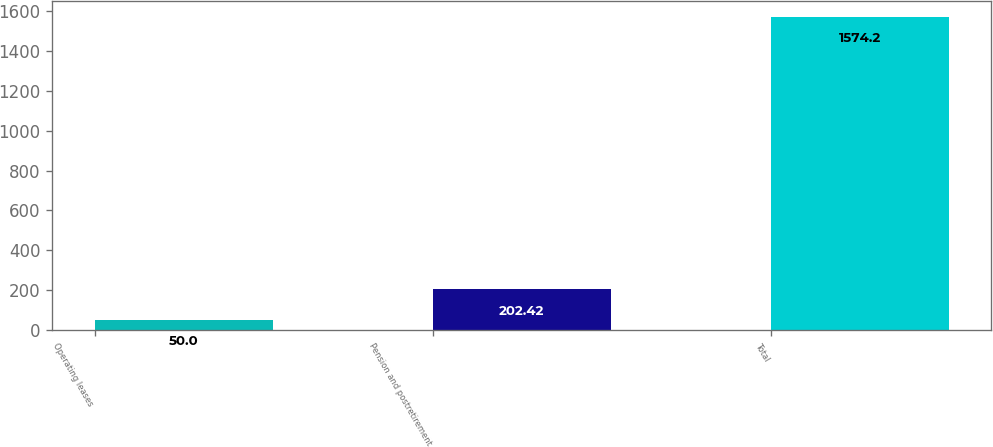<chart> <loc_0><loc_0><loc_500><loc_500><bar_chart><fcel>Operating leases<fcel>Pension and postretirement<fcel>Total<nl><fcel>50<fcel>202.42<fcel>1574.2<nl></chart> 